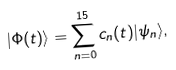Convert formula to latex. <formula><loc_0><loc_0><loc_500><loc_500>| \Phi ( t ) \rangle = \sum _ { n = 0 } ^ { 1 5 } c _ { n } ( t ) | \psi _ { n } \rangle ,</formula> 